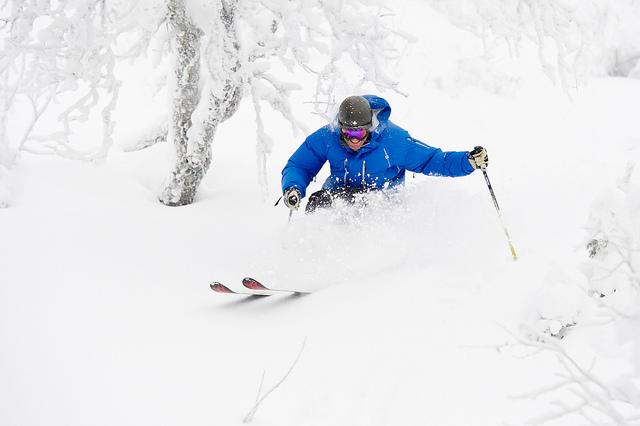Are the trees covered in snow?
Give a very brief answer. Yes. What is the primary color of the man's jacket?
Be succinct. Blue. Is the man moving fast?
Write a very short answer. Yes. Could this be powder skiing?
Quick response, please. Yes. Is this man skiing?
Be succinct. Yes. 